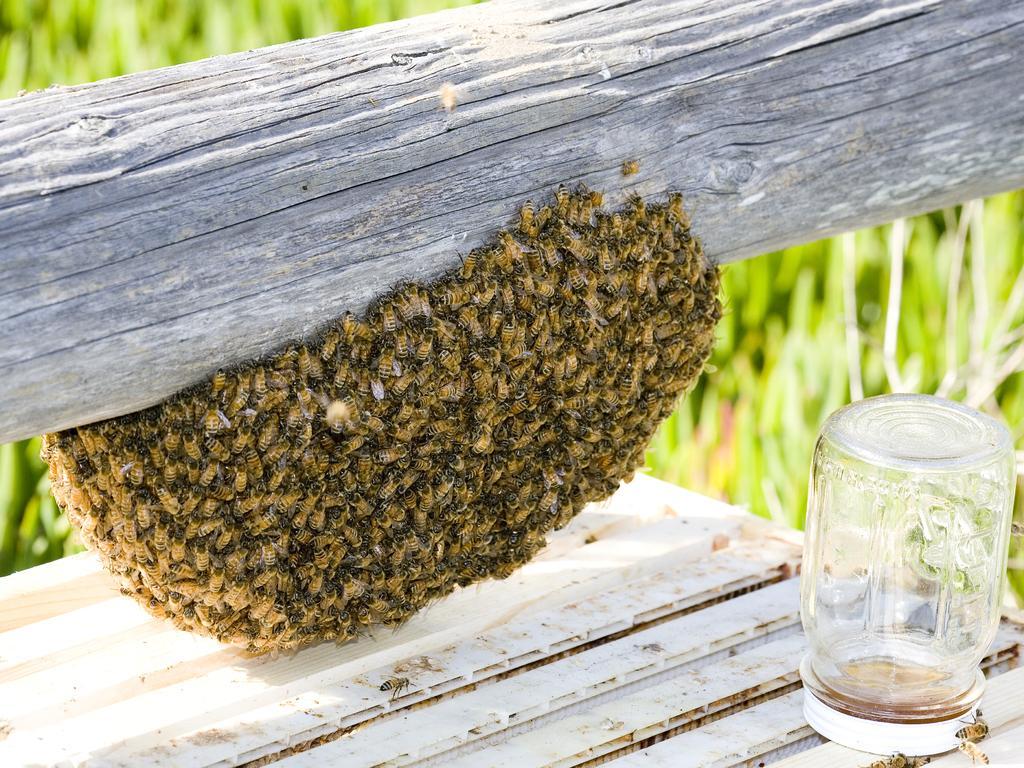Please provide a concise description of this image. In this picture I can see a honeycomb with honey bees, which is to the tree trunk, there is a glass jar with a lid on an object, and there is blur background. 